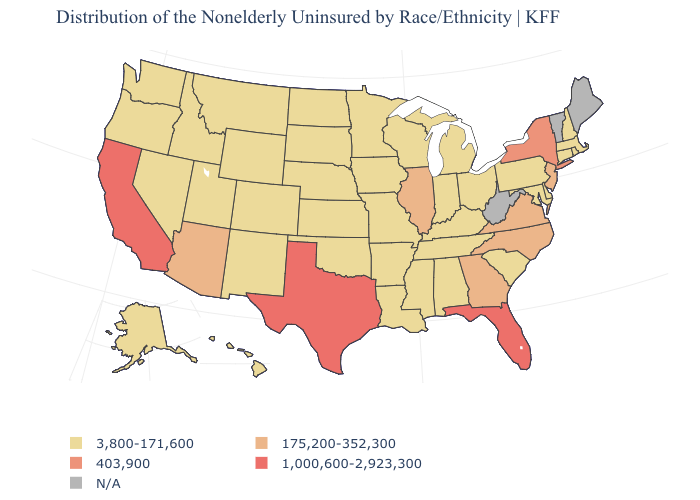What is the lowest value in the USA?
Keep it brief. 3,800-171,600. What is the value of Pennsylvania?
Keep it brief. 3,800-171,600. What is the lowest value in the MidWest?
Write a very short answer. 3,800-171,600. Among the states that border Pennsylvania , which have the highest value?
Short answer required. New York. Among the states that border Indiana , which have the highest value?
Concise answer only. Illinois. Which states have the highest value in the USA?
Be succinct. California, Florida, Texas. Among the states that border Louisiana , which have the lowest value?
Concise answer only. Arkansas, Mississippi. Does Rhode Island have the highest value in the Northeast?
Answer briefly. No. Name the states that have a value in the range 3,800-171,600?
Give a very brief answer. Alabama, Alaska, Arkansas, Colorado, Connecticut, Delaware, Hawaii, Idaho, Indiana, Iowa, Kansas, Kentucky, Louisiana, Maryland, Massachusetts, Michigan, Minnesota, Mississippi, Missouri, Montana, Nebraska, Nevada, New Hampshire, New Mexico, North Dakota, Ohio, Oklahoma, Oregon, Pennsylvania, Rhode Island, South Carolina, South Dakota, Tennessee, Utah, Washington, Wisconsin, Wyoming. Which states hav the highest value in the South?
Be succinct. Florida, Texas. Which states have the lowest value in the USA?
Be succinct. Alabama, Alaska, Arkansas, Colorado, Connecticut, Delaware, Hawaii, Idaho, Indiana, Iowa, Kansas, Kentucky, Louisiana, Maryland, Massachusetts, Michigan, Minnesota, Mississippi, Missouri, Montana, Nebraska, Nevada, New Hampshire, New Mexico, North Dakota, Ohio, Oklahoma, Oregon, Pennsylvania, Rhode Island, South Carolina, South Dakota, Tennessee, Utah, Washington, Wisconsin, Wyoming. What is the value of New Hampshire?
Concise answer only. 3,800-171,600. What is the value of Ohio?
Write a very short answer. 3,800-171,600. 